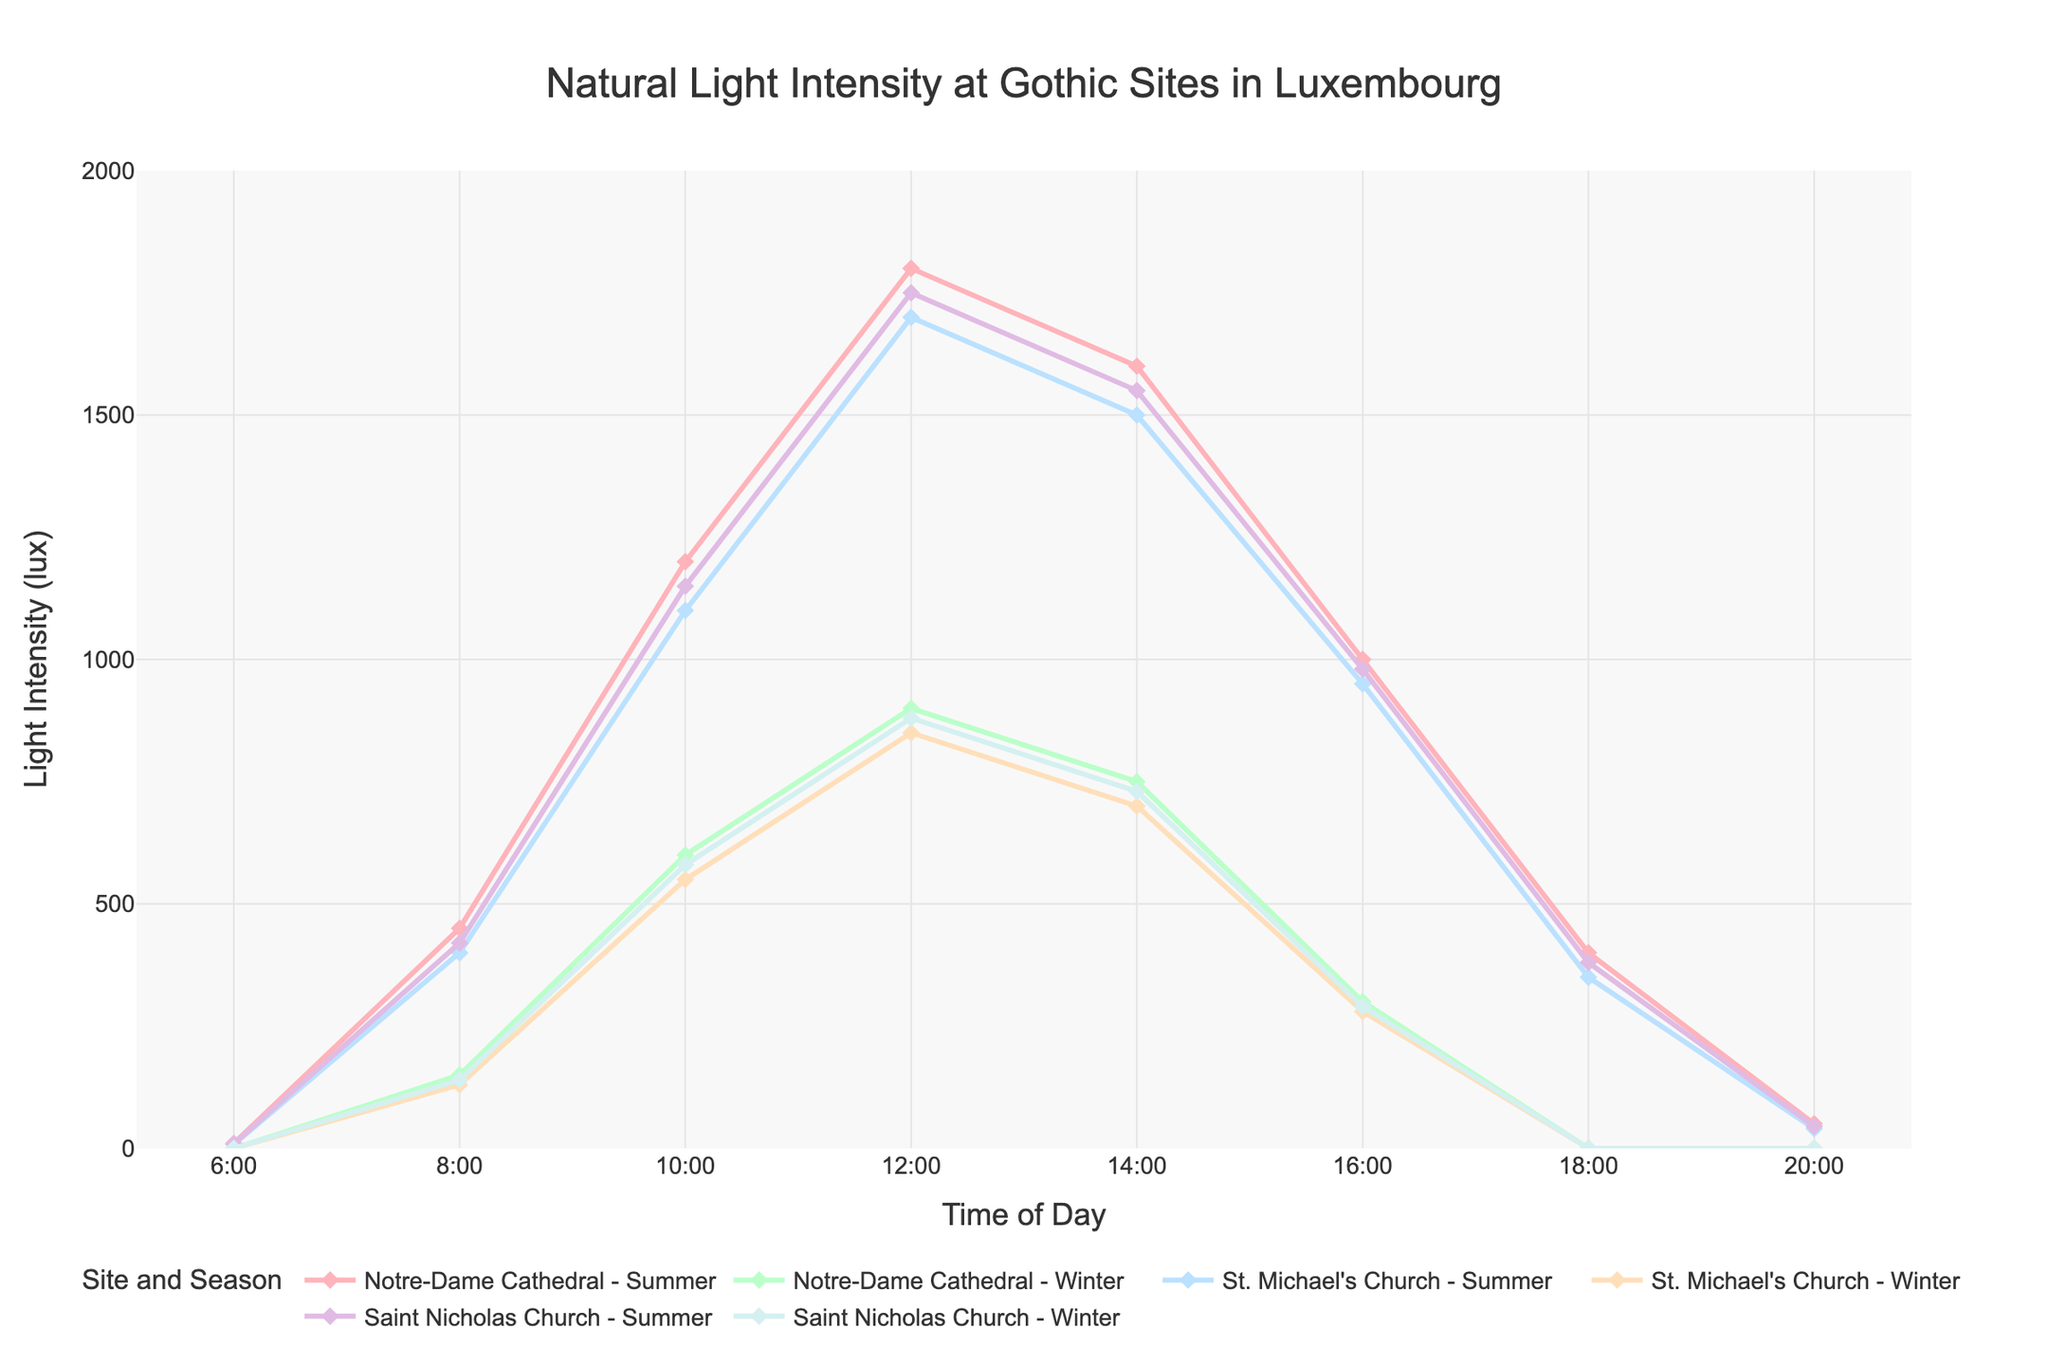What time of day does Notre-Dame Cathedral experience peak light intensity in Summer? The script generates a line plot showing light intensity levels across different times of day. To find the peak light intensity for Notre-Dame Cathedral in Summer, look at the point where the 'Notre-Dame Cathedral (Summer)' line reaches its highest value. At 12:00, the line is at 1800 lux, the highest point in the day.
Answer: 12:00 Compare the light intensity at 10:00 between St. Michael's Church in Summer and Notre-Dame Cathedral in Winter. Which one is higher? Locate the points for 10:00 on the plot. The 'St. Michael's Church (Summer)' line is at 1100 lux and the 'Notre-Dame Cathedral (Winter)' line is at 600 lux. A comparison shows that St. Michael's Church has a higher intensity.
Answer: St. Michael's Church (Summer) What is the difference in light intensity at 14:00 between Summer and Winter for Saint Nicholas Church? At 14:00, identify the points on the 'Saint Nicholas Church (Summer)' and 'Saint Nicholas Church (Winter)' lines. The values are 1550 lux and 730 lux, respectively. The difference is calculated as 1550 - 730 = 820 lux.
Answer: 820 lux How does the light intensity at 16:00 compare across all three sites in Winter? Which site has the lowest intensity? Locate the 16:00 points on the lines for 'Notre-Dame Cathedral (Winter),' 'St. Michael's Church (Winter),' and 'Saint Nicholas Church (Winter).' Their values are 300 lux, 280 lux, and 290 lux, respectively. St. Michael's Church has the lowest intensity.
Answer: St. Michael's Church What are the average light intensities at 18:00 for all three sites in Summer? At 18:00, identify the points for 'Notre-Dame Cathedral (Summer),' 'St. Michael's Church (Summer),' and 'Saint Nicholas Church (Summer).' The values are 400 lux, 350 lux, and 380 lux, respectively. The average is calculated as (400 + 350 + 380) / 3 = 376.67 lux.
Answer: 376.67 lux At what times in Winter does St. Michael's Church experience zero light intensity? Observe the 'St. Michael's Church (Winter)' line. The points where the light intensity is zero are at 6:00, 18:00, and 20:00.
Answer: 6:00, 18:00, 20:00 Which site experiences the highest light intensity at 8:00 during Winter? Locate the 8:00 points for all Winter lines. 'Notre-Dame Cathedral (Winter),' 'St. Michael's Church (Winter),' and 'Saint Nicholas Church (Winter)' have values of 150 lux, 130 lux, and 140 lux, respectively. Notre-Dame Cathedral has the highest intensity.
Answer: Notre-Dame Cathedral Does Saint Nicholas Church experience any light intensity at 20:00 in both seasons? Check the 'Saint Nicholas Church (Summer)' and 'Saint Nicholas Church (Winter)' lines at 20:00. Both lines are at 0 lux, indicating no light intensity.
Answer: No What's the total light intensity at 12:00 for all sites combined in Summer? Find the 12:00 points for 'Notre-Dame Cathedral (Summer),' 'St. Michael's Church (Summer),' and 'Saint Nicholas Church (Summer).' Their values are 1800 lux, 1700 lux, and 1750 lux, respectively. The total is 1800 + 1700 + 1750 = 5250 lux.
Answer: 5250 lux 